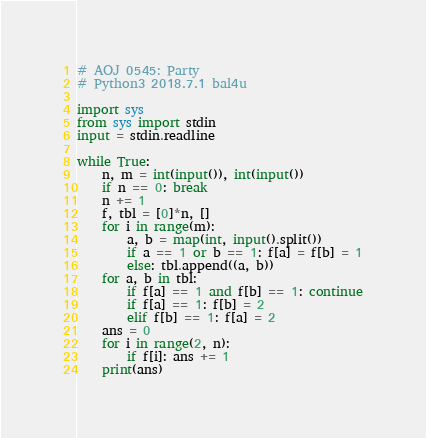Convert code to text. <code><loc_0><loc_0><loc_500><loc_500><_Python_># AOJ 0545: Party
# Python3 2018.7.1 bal4u

import sys
from sys import stdin
input = stdin.readline

while True:
	n, m = int(input()), int(input())
	if n == 0: break
	n += 1
	f, tbl = [0]*n, []
	for i in range(m):
		a, b = map(int, input().split())
		if a == 1 or b == 1: f[a] = f[b] = 1
		else: tbl.append((a, b))
	for a, b in tbl:
		if f[a] == 1 and f[b] == 1: continue
		if f[a] == 1: f[b] = 2
		elif f[b] == 1: f[a] = 2
	ans = 0
	for i in range(2, n):
		if f[i]: ans += 1
	print(ans)
</code> 